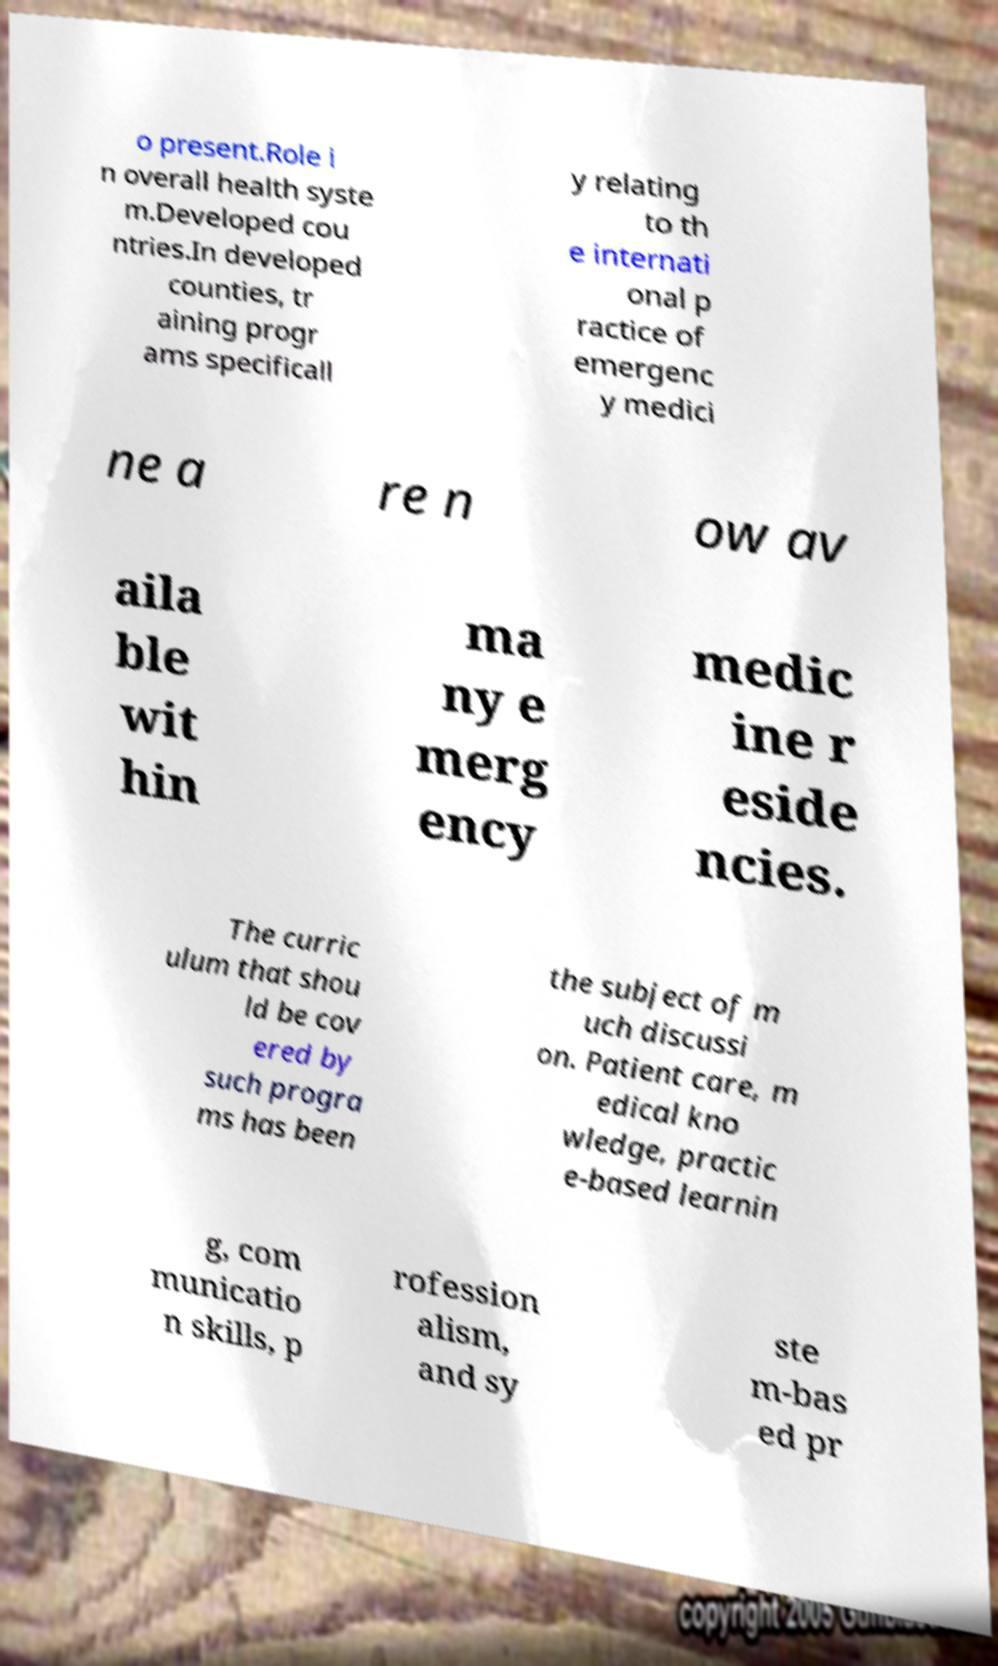For documentation purposes, I need the text within this image transcribed. Could you provide that? o present.Role i n overall health syste m.Developed cou ntries.In developed counties, tr aining progr ams specificall y relating to th e internati onal p ractice of emergenc y medici ne a re n ow av aila ble wit hin ma ny e merg ency medic ine r eside ncies. The curric ulum that shou ld be cov ered by such progra ms has been the subject of m uch discussi on. Patient care, m edical kno wledge, practic e-based learnin g, com municatio n skills, p rofession alism, and sy ste m-bas ed pr 